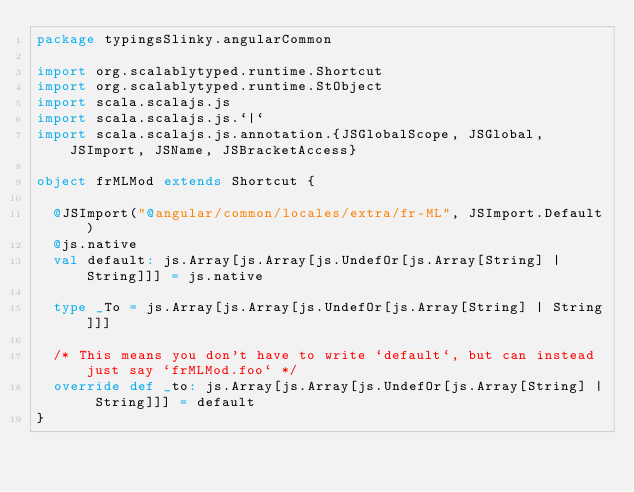<code> <loc_0><loc_0><loc_500><loc_500><_Scala_>package typingsSlinky.angularCommon

import org.scalablytyped.runtime.Shortcut
import org.scalablytyped.runtime.StObject
import scala.scalajs.js
import scala.scalajs.js.`|`
import scala.scalajs.js.annotation.{JSGlobalScope, JSGlobal, JSImport, JSName, JSBracketAccess}

object frMLMod extends Shortcut {
  
  @JSImport("@angular/common/locales/extra/fr-ML", JSImport.Default)
  @js.native
  val default: js.Array[js.Array[js.UndefOr[js.Array[String] | String]]] = js.native
  
  type _To = js.Array[js.Array[js.UndefOr[js.Array[String] | String]]]
  
  /* This means you don't have to write `default`, but can instead just say `frMLMod.foo` */
  override def _to: js.Array[js.Array[js.UndefOr[js.Array[String] | String]]] = default
}
</code> 